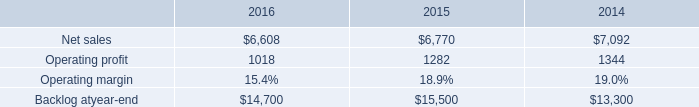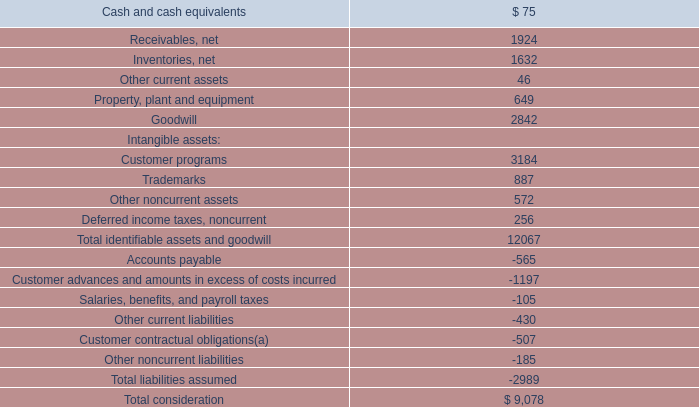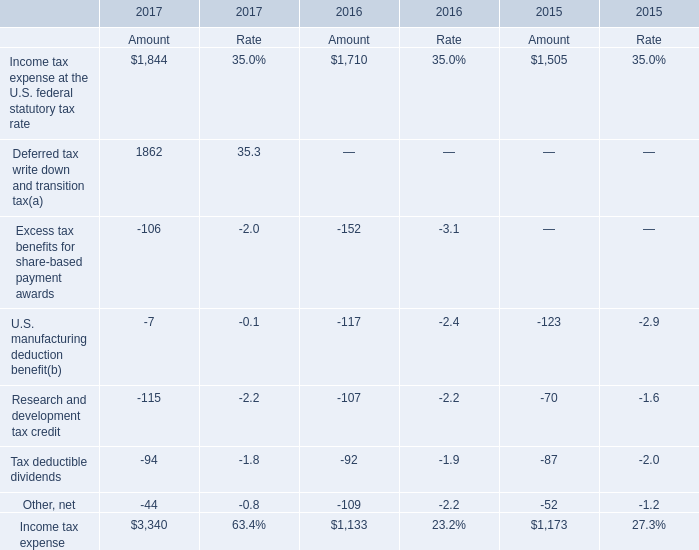What is the growing rate of Tax deductible dividends in the years with the least Income tax expense? (in %) 
Answer: -0.05434782608695652. 